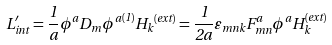Convert formula to latex. <formula><loc_0><loc_0><loc_500><loc_500>L _ { i n t } ^ { \prime } = \frac { 1 } { a } \phi ^ { a } D _ { m } { \phi ^ { a } } ^ { ( 1 ) } { H _ { k } } ^ { ( e x t ) } = \frac { 1 } { 2 a } \varepsilon _ { m n k } F _ { m n } ^ { a } \phi ^ { a } H _ { k } ^ { ( e x t ) }</formula> 